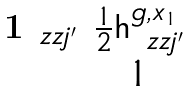<formula> <loc_0><loc_0><loc_500><loc_500>\begin{matrix} \mathbf 1 _ { \ z z j ^ { \prime } } & \frac { 1 } { 2 } { \mathsf h } _ { \ z z j ^ { \prime } } ^ { g , x _ { 1 } } \\ & 1 \end{matrix}</formula> 